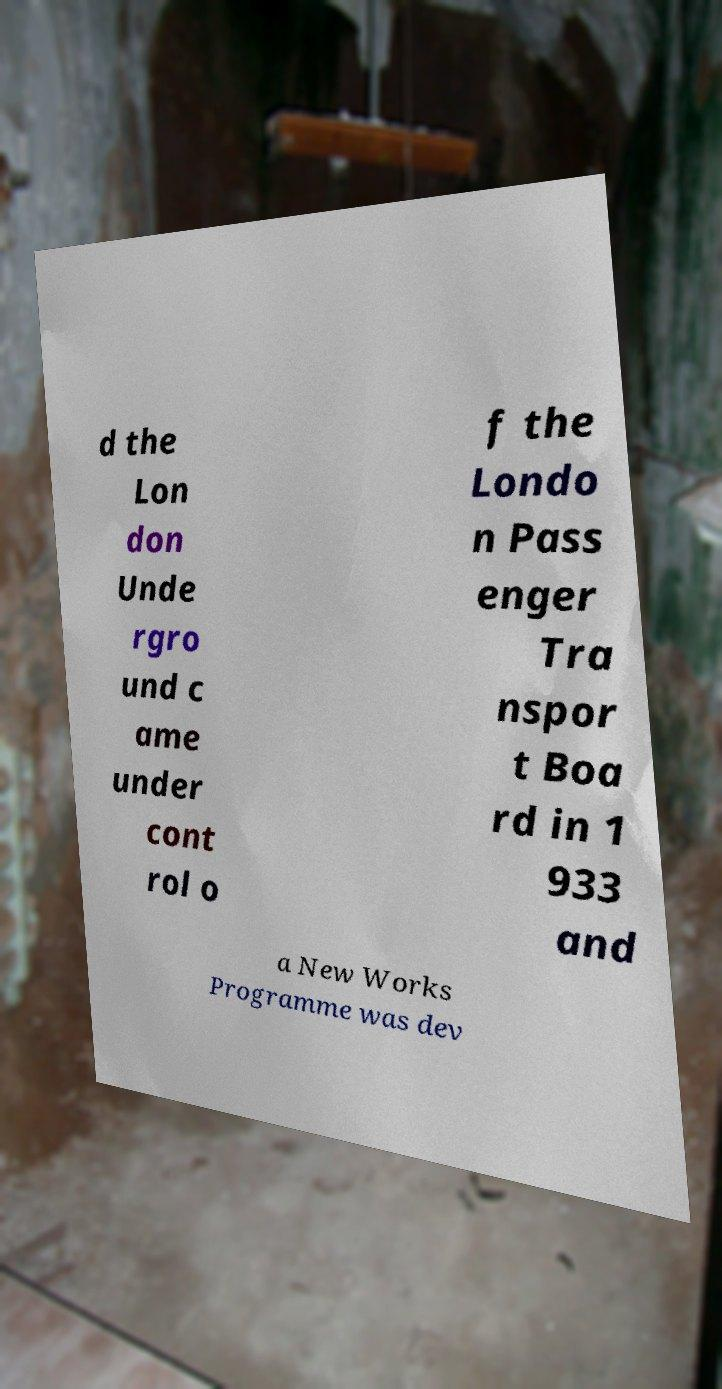What messages or text are displayed in this image? I need them in a readable, typed format. d the Lon don Unde rgro und c ame under cont rol o f the Londo n Pass enger Tra nspor t Boa rd in 1 933 and a New Works Programme was dev 